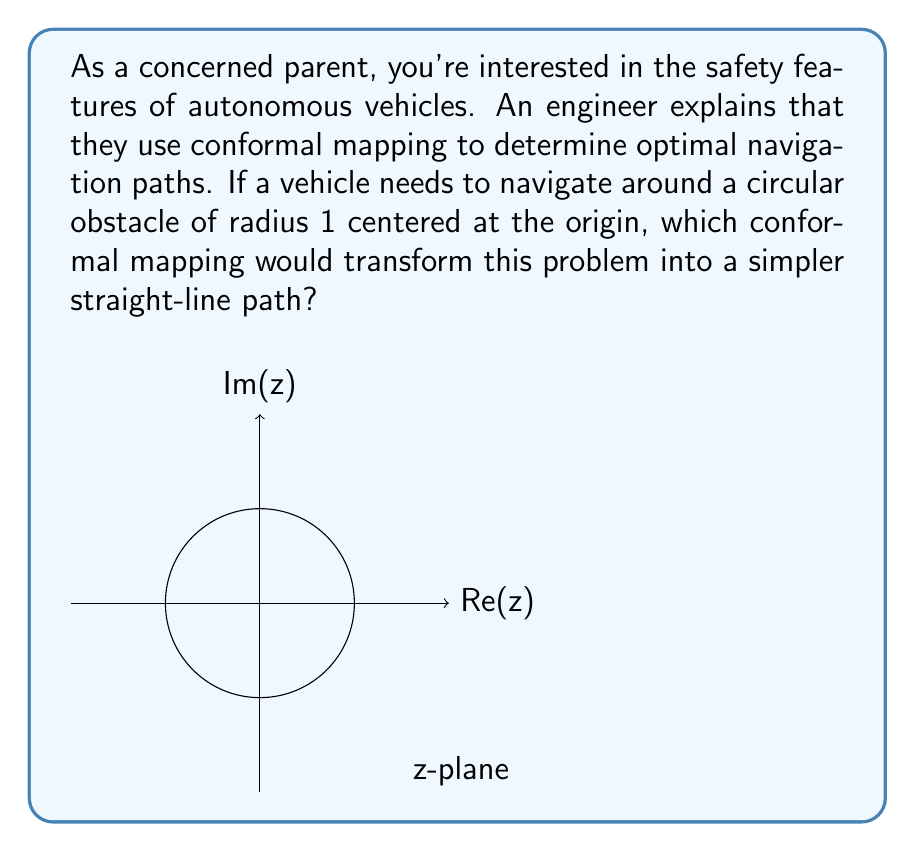Provide a solution to this math problem. To solve this problem, we need to consider the properties of conformal mappings and their effect on the geometry of the complex plane. Here's a step-by-step explanation:

1) The given scenario presents a circular obstacle in the complex z-plane. We need to find a mapping that transforms this circular obstacle into a straight line, simplifying the navigation problem.

2) One of the most useful conformal mappings for this type of problem is the Joukowski transformation, defined as:

   $$w = z + \frac{1}{z}$$

3) This transformation has the following properties:
   - It maps the unit circle in the z-plane to a line segment on the real axis in the w-plane.
   - Points outside the unit circle in the z-plane are mapped to points outside this line segment in the w-plane.

4) To see why this works, let's consider a point on the unit circle in the z-plane:
   $$z = e^{i\theta} = \cos\theta + i\sin\theta$$

5) Applying the Joukowski transformation:

   $$\begin{align}
   w &= e^{i\theta} + \frac{1}{e^{i\theta}} \\
   &= (\cos\theta + i\sin\theta) + (\cos\theta - i\sin\theta) \\
   &= 2\cos\theta
   \end{align}$$

6) This result is always real and ranges from -2 to 2 as $\theta$ varies from 0 to $2\pi$, confirming that the unit circle is indeed mapped to a line segment on the real axis.

7) For the autonomous vehicle, this transformation simplifies the navigation problem. Instead of planning a path around a circular obstacle, the vehicle can now plan a straight-line path in the transformed w-plane, avoiding the line segment.

8) The inverse transformation can then be used to map this straight-line path back to the original z-plane, providing the optimal curved path around the circular obstacle.
Answer: Joukowski transformation: $w = z + \frac{1}{z}$ 